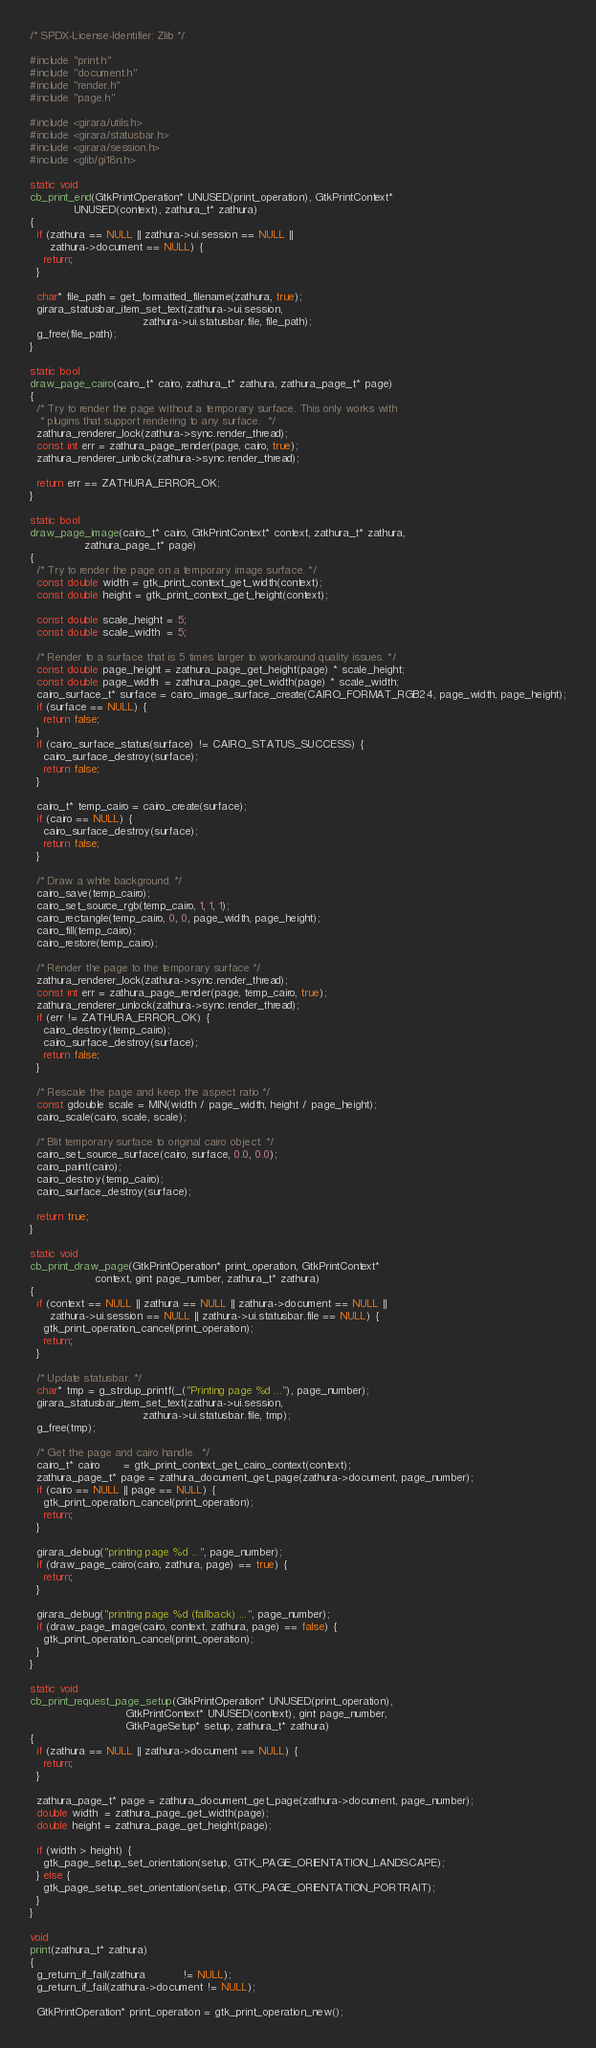Convert code to text. <code><loc_0><loc_0><loc_500><loc_500><_C_>/* SPDX-License-Identifier: Zlib */

#include "print.h"
#include "document.h"
#include "render.h"
#include "page.h"

#include <girara/utils.h>
#include <girara/statusbar.h>
#include <girara/session.h>
#include <glib/gi18n.h>

static void
cb_print_end(GtkPrintOperation* UNUSED(print_operation), GtkPrintContext*
             UNUSED(context), zathura_t* zathura)
{
  if (zathura == NULL || zathura->ui.session == NULL ||
      zathura->document == NULL) {
    return;
  }

  char* file_path = get_formatted_filename(zathura, true);
  girara_statusbar_item_set_text(zathura->ui.session,
                                 zathura->ui.statusbar.file, file_path);
  g_free(file_path);
}

static bool
draw_page_cairo(cairo_t* cairo, zathura_t* zathura, zathura_page_t* page)
{
  /* Try to render the page without a temporary surface. This only works with
   * plugins that support rendering to any surface.  */
  zathura_renderer_lock(zathura->sync.render_thread);
  const int err = zathura_page_render(page, cairo, true);
  zathura_renderer_unlock(zathura->sync.render_thread);

  return err == ZATHURA_ERROR_OK;
}

static bool
draw_page_image(cairo_t* cairo, GtkPrintContext* context, zathura_t* zathura,
                zathura_page_t* page)
{
  /* Try to render the page on a temporary image surface. */
  const double width = gtk_print_context_get_width(context);
  const double height = gtk_print_context_get_height(context);

  const double scale_height = 5;
  const double scale_width  = 5;

  /* Render to a surface that is 5 times larger to workaround quality issues. */
  const double page_height = zathura_page_get_height(page) * scale_height;
  const double page_width  = zathura_page_get_width(page) * scale_width;
  cairo_surface_t* surface = cairo_image_surface_create(CAIRO_FORMAT_RGB24, page_width, page_height);
  if (surface == NULL) {
    return false;
  }
  if (cairo_surface_status(surface) != CAIRO_STATUS_SUCCESS) {
    cairo_surface_destroy(surface);
    return false;
  }

  cairo_t* temp_cairo = cairo_create(surface);
  if (cairo == NULL) {
    cairo_surface_destroy(surface);
    return false;
  }

  /* Draw a white background. */
  cairo_save(temp_cairo);
  cairo_set_source_rgb(temp_cairo, 1, 1, 1);
  cairo_rectangle(temp_cairo, 0, 0, page_width, page_height);
  cairo_fill(temp_cairo);
  cairo_restore(temp_cairo);

  /* Render the page to the temporary surface */
  zathura_renderer_lock(zathura->sync.render_thread);
  const int err = zathura_page_render(page, temp_cairo, true);
  zathura_renderer_unlock(zathura->sync.render_thread);
  if (err != ZATHURA_ERROR_OK) {
    cairo_destroy(temp_cairo);
    cairo_surface_destroy(surface);
    return false;
  }

  /* Rescale the page and keep the aspect ratio */
  const gdouble scale = MIN(width / page_width, height / page_height);
  cairo_scale(cairo, scale, scale);

  /* Blit temporary surface to original cairo object. */
  cairo_set_source_surface(cairo, surface, 0.0, 0.0);
  cairo_paint(cairo);
  cairo_destroy(temp_cairo);
  cairo_surface_destroy(surface);

  return true;
}

static void
cb_print_draw_page(GtkPrintOperation* print_operation, GtkPrintContext*
                   context, gint page_number, zathura_t* zathura)
{
  if (context == NULL || zathura == NULL || zathura->document == NULL ||
      zathura->ui.session == NULL || zathura->ui.statusbar.file == NULL) {
    gtk_print_operation_cancel(print_operation);
    return;
  }

  /* Update statusbar. */
  char* tmp = g_strdup_printf(_("Printing page %d ..."), page_number);
  girara_statusbar_item_set_text(zathura->ui.session,
                                 zathura->ui.statusbar.file, tmp);
  g_free(tmp);

  /* Get the page and cairo handle.  */
  cairo_t* cairo       = gtk_print_context_get_cairo_context(context);
  zathura_page_t* page = zathura_document_get_page(zathura->document, page_number);
  if (cairo == NULL || page == NULL) {
    gtk_print_operation_cancel(print_operation);
    return;
  }

  girara_debug("printing page %d ...", page_number);
  if (draw_page_cairo(cairo, zathura, page) == true) {
    return;
  }

  girara_debug("printing page %d (fallback) ...", page_number);
  if (draw_page_image(cairo, context, zathura, page) == false) {
    gtk_print_operation_cancel(print_operation);
  }
}

static void
cb_print_request_page_setup(GtkPrintOperation* UNUSED(print_operation),
                            GtkPrintContext* UNUSED(context), gint page_number,
                            GtkPageSetup* setup, zathura_t* zathura)
{
  if (zathura == NULL || zathura->document == NULL) {
    return;
  }

  zathura_page_t* page = zathura_document_get_page(zathura->document, page_number);
  double width  = zathura_page_get_width(page);
  double height = zathura_page_get_height(page);

  if (width > height) {
    gtk_page_setup_set_orientation(setup, GTK_PAGE_ORIENTATION_LANDSCAPE);
  } else {
    gtk_page_setup_set_orientation(setup, GTK_PAGE_ORIENTATION_PORTRAIT);
  }
}

void
print(zathura_t* zathura)
{
  g_return_if_fail(zathura           != NULL);
  g_return_if_fail(zathura->document != NULL);

  GtkPrintOperation* print_operation = gtk_print_operation_new();
</code> 